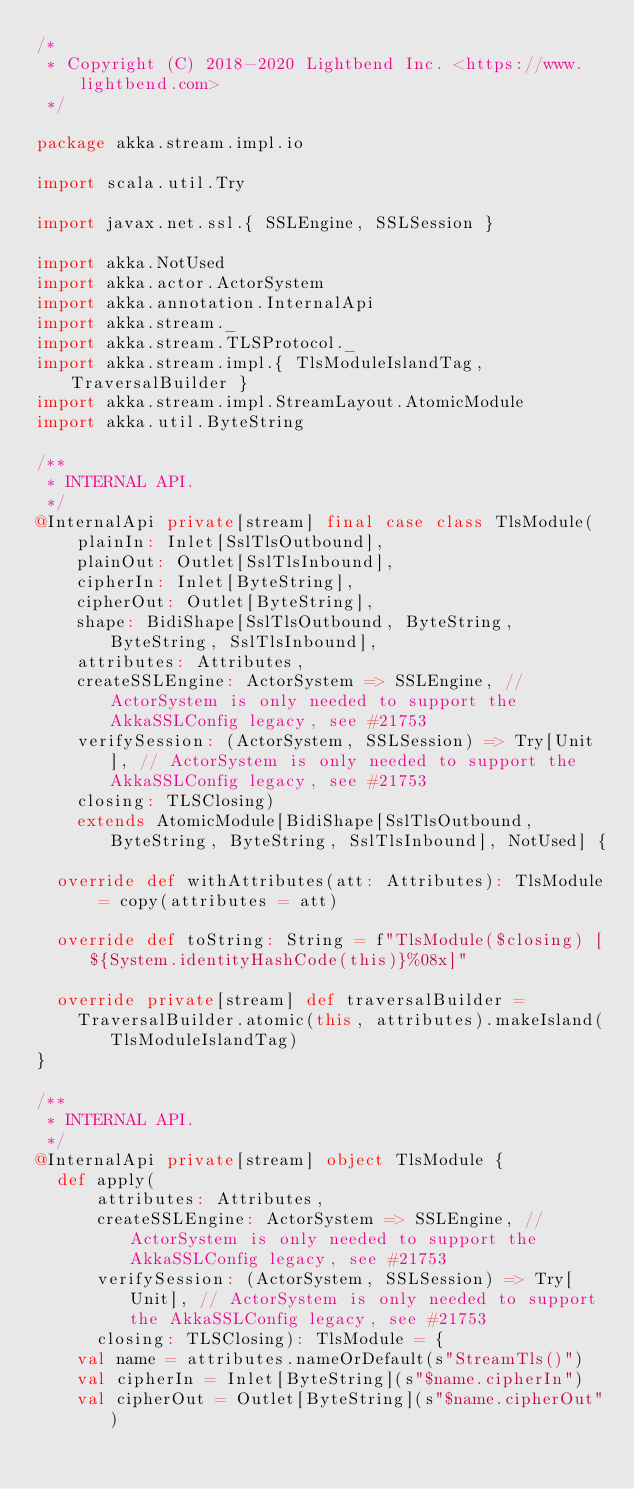Convert code to text. <code><loc_0><loc_0><loc_500><loc_500><_Scala_>/*
 * Copyright (C) 2018-2020 Lightbend Inc. <https://www.lightbend.com>
 */

package akka.stream.impl.io

import scala.util.Try

import javax.net.ssl.{ SSLEngine, SSLSession }

import akka.NotUsed
import akka.actor.ActorSystem
import akka.annotation.InternalApi
import akka.stream._
import akka.stream.TLSProtocol._
import akka.stream.impl.{ TlsModuleIslandTag, TraversalBuilder }
import akka.stream.impl.StreamLayout.AtomicModule
import akka.util.ByteString

/**
 * INTERNAL API.
 */
@InternalApi private[stream] final case class TlsModule(
    plainIn: Inlet[SslTlsOutbound],
    plainOut: Outlet[SslTlsInbound],
    cipherIn: Inlet[ByteString],
    cipherOut: Outlet[ByteString],
    shape: BidiShape[SslTlsOutbound, ByteString, ByteString, SslTlsInbound],
    attributes: Attributes,
    createSSLEngine: ActorSystem => SSLEngine, // ActorSystem is only needed to support the AkkaSSLConfig legacy, see #21753
    verifySession: (ActorSystem, SSLSession) => Try[Unit], // ActorSystem is only needed to support the AkkaSSLConfig legacy, see #21753
    closing: TLSClosing)
    extends AtomicModule[BidiShape[SslTlsOutbound, ByteString, ByteString, SslTlsInbound], NotUsed] {

  override def withAttributes(att: Attributes): TlsModule = copy(attributes = att)

  override def toString: String = f"TlsModule($closing) [${System.identityHashCode(this)}%08x]"

  override private[stream] def traversalBuilder =
    TraversalBuilder.atomic(this, attributes).makeIsland(TlsModuleIslandTag)
}

/**
 * INTERNAL API.
 */
@InternalApi private[stream] object TlsModule {
  def apply(
      attributes: Attributes,
      createSSLEngine: ActorSystem => SSLEngine, // ActorSystem is only needed to support the AkkaSSLConfig legacy, see #21753
      verifySession: (ActorSystem, SSLSession) => Try[Unit], // ActorSystem is only needed to support the AkkaSSLConfig legacy, see #21753
      closing: TLSClosing): TlsModule = {
    val name = attributes.nameOrDefault(s"StreamTls()")
    val cipherIn = Inlet[ByteString](s"$name.cipherIn")
    val cipherOut = Outlet[ByteString](s"$name.cipherOut")</code> 